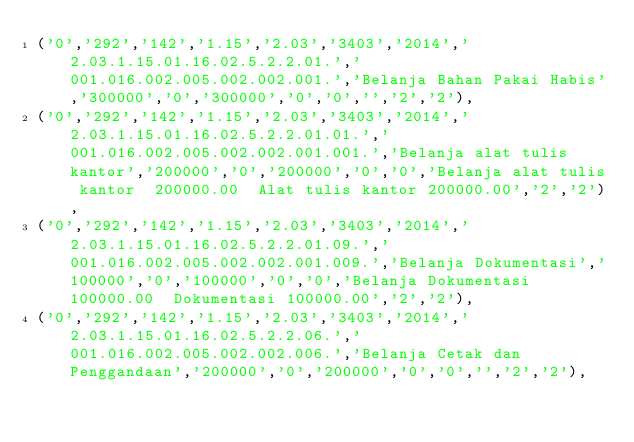<code> <loc_0><loc_0><loc_500><loc_500><_SQL_>('0','292','142','1.15','2.03','3403','2014','2.03.1.15.01.16.02.5.2.2.01.','001.016.002.005.002.002.001.','Belanja Bahan Pakai Habis','300000','0','300000','0','0','','2','2'),
('0','292','142','1.15','2.03','3403','2014','2.03.1.15.01.16.02.5.2.2.01.01.','001.016.002.005.002.002.001.001.','Belanja alat tulis kantor','200000','0','200000','0','0','Belanja alat tulis kantor  200000.00  Alat tulis kantor 200000.00','2','2'),
('0','292','142','1.15','2.03','3403','2014','2.03.1.15.01.16.02.5.2.2.01.09.','001.016.002.005.002.002.001.009.','Belanja Dokumentasi','100000','0','100000','0','0','Belanja Dokumentasi  100000.00  Dokumentasi 100000.00','2','2'),
('0','292','142','1.15','2.03','3403','2014','2.03.1.15.01.16.02.5.2.2.06.','001.016.002.005.002.002.006.','Belanja Cetak dan Penggandaan','200000','0','200000','0','0','','2','2'),</code> 